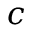Convert formula to latex. <formula><loc_0><loc_0><loc_500><loc_500>c</formula> 